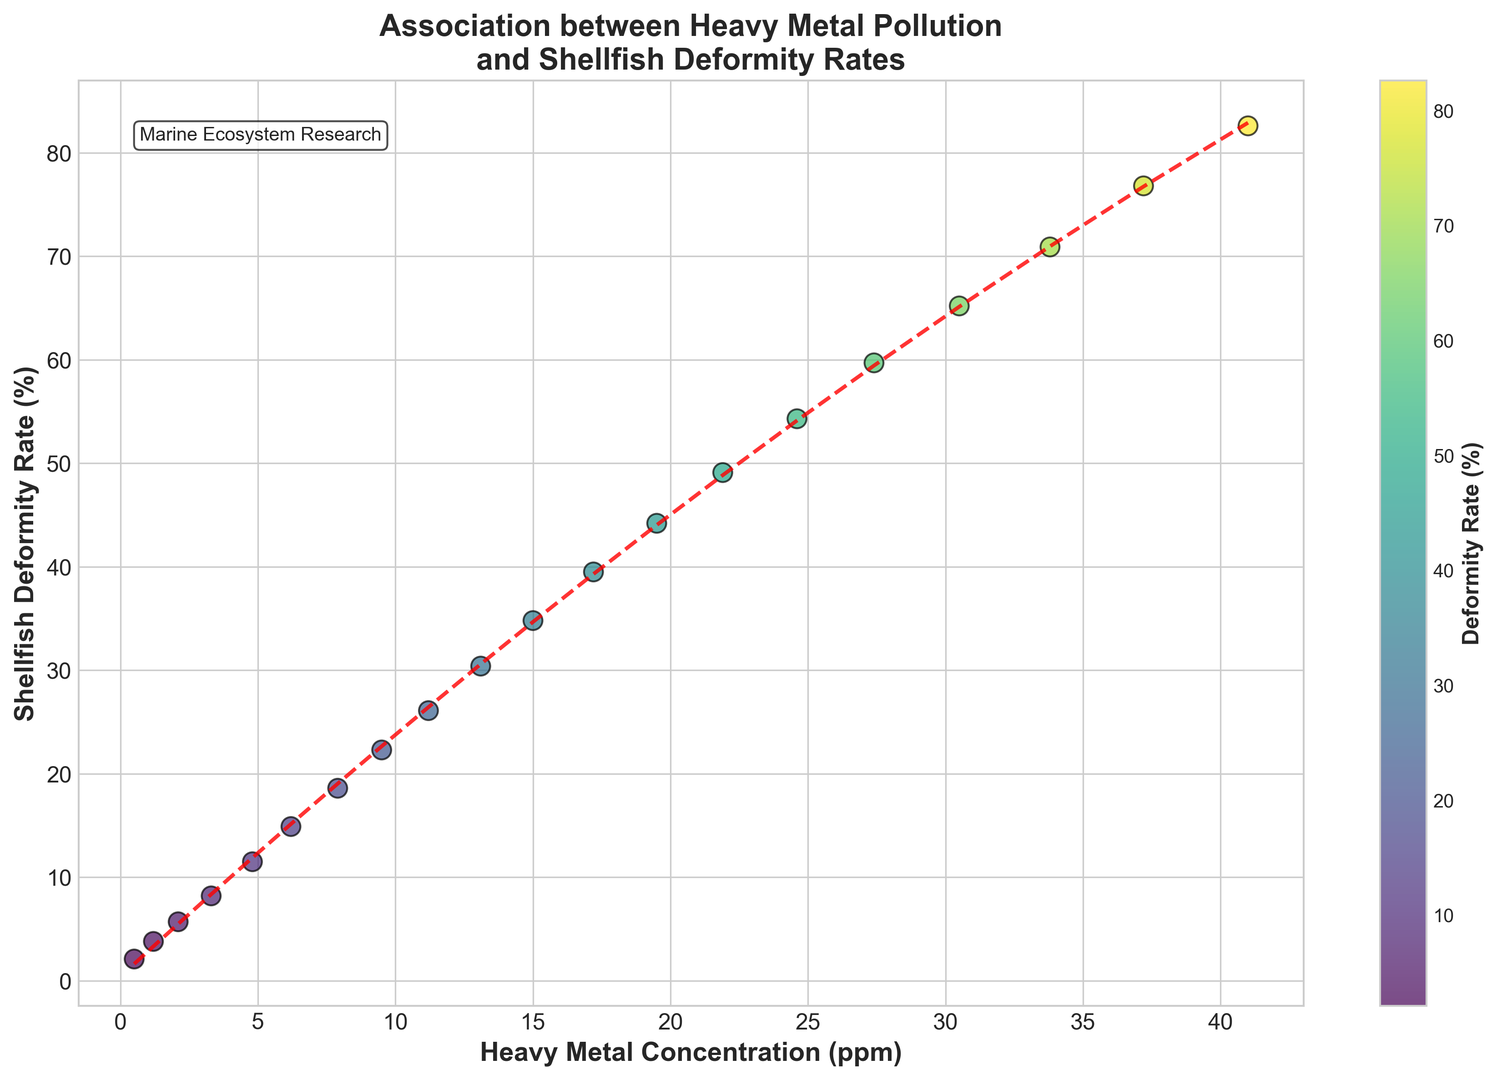What is the general trend observed between heavy metal concentration and shellfish deformity rates? The scatter plot shows that as the heavy metal concentration (in ppm) increases, the shellfish deformity rate (in %) also increases, suggesting a positive correlation. This trend is further emphasized by the red dashed line representing the polynomial fit, which also slopes upwards.
Answer: Positive correlation At what heavy metal concentration ppm does the shellfish deformity rate reach approximately 50%? Referring to the scatter plot, the deformity rate reaches approximately 50% at a heavy metal concentration of around 22 ppm. This is visually derived from the point where the deformity rate on the y-axis intersects around 50% on the polynomial trend line.
Answer: 22 ppm Which data point has the highest shellfish deformity rate, and what is its heavy metal concentration? The data point with the highest shellfish deformity rate is at the topmost point of the scatter plot, which corresponds to a deformity rate of 82.6%. The associated heavy metal concentration for this point is 41.0 ppm.
Answer: 82.6%, 41.0 ppm Compare the shellfish deformity rates at 5 ppm and 10 ppm heavy metal concentrations. Which is higher and by how much? At around 5 ppm, the shellfish deformity rate is approximately 11.5%. At around 10 ppm, the deformity rate is approximately 22.3%. To find the difference, subtract 11.5% from 22.3%, resulting in a higher deformity rate by 10.8% at 10 ppm.
Answer: 10 ppm, 10.8% Is the increase in shellfish deformity rates linear with the increase in heavy metal concentrations? By observing the scatter plot and the red dashed polynomial fit line, it is apparent that the increase in deformity rates is not linear. The polynomial fit suggests a curvilinear relationship where the rate of increase accelerates as the heavy metal concentration increases.
Answer: No, curvilinear For a heavy metal concentration of 15 ppm, what is the approximate deformity rate? Referring to the scatter plot, for a heavy metal concentration of 15 ppm, the corresponding shellfish deformity rate is approximately 34.8%. This is derived directly from the data point on the plot.
Answer: 34.8% What visual elements of the plot help convey the relationship between the variables? The scatter plot utilizes colors from the viridis colormap to represent deformity rates and a red dashed line to show the polynomial fit, emphasizing the trend. The black edges around scatter points make them distinct and the grid lines aid in better viewing of data relationships.
Answer: Colored scatter points, red dashed line, black edges, grid lines By how much does the shellfish deformity rate increase when moving from 30 ppm to 35 ppm in heavy metal concentration? At 30.5 ppm, the deformity rate is about 65.2%. At 33.8 ppm, the deformity rate is about 70.9%. The increase in deformity rate moving from 30 ppm to 35 ppm is thus 70.9% - 65.2% = 5.7%.
Answer: 5.7% If the heavy metal concentration increases by 10 ppm from 20 ppm, what is the approximate increase in deformity rate? At 20 ppm, the deformity rate is around 44.2%. At 30 ppm, the deformity rate is around 65.2%. The increase in deformity rate for a 10 ppm concentration increase is 65.2% - 44.2% = 21%.
Answer: 21% 